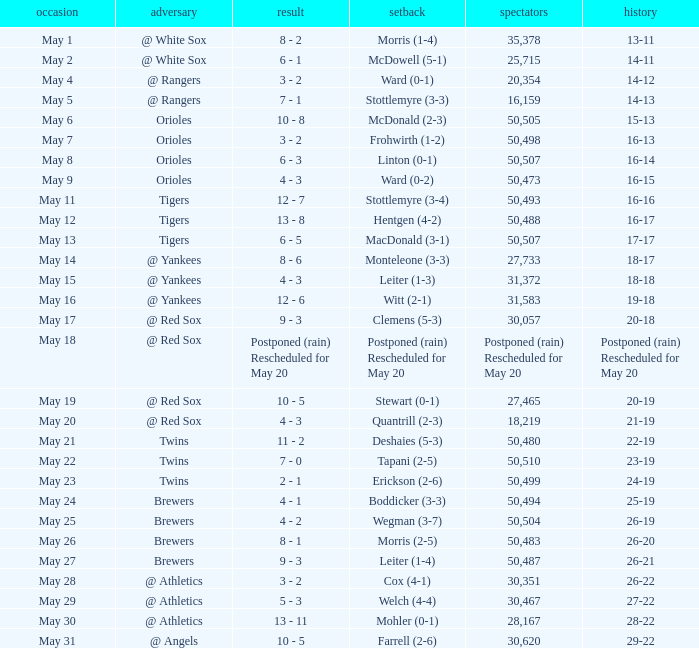On May 29 which team had the loss? Welch (4-4). 